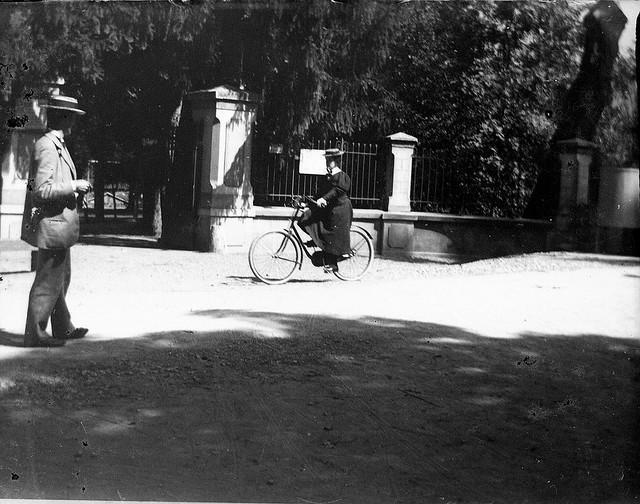How many people are there?
Give a very brief answer. 2. 